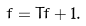<formula> <loc_0><loc_0><loc_500><loc_500>f = T f + 1 .</formula> 